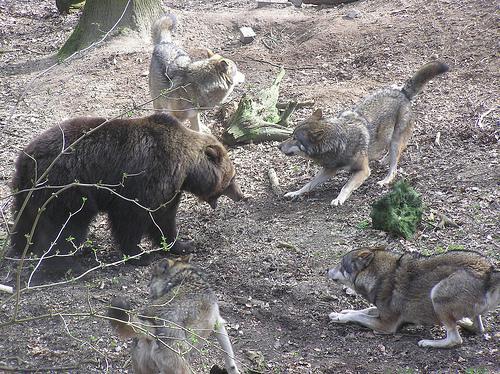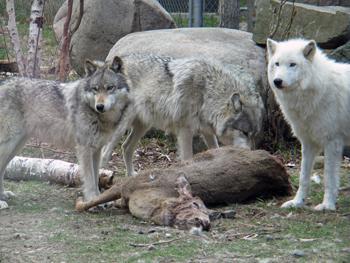The first image is the image on the left, the second image is the image on the right. Given the left and right images, does the statement "One of the images features a single animal." hold true? Answer yes or no. No. The first image is the image on the left, the second image is the image on the right. Examine the images to the left and right. Is the description "There are three wolves in the image pair." accurate? Answer yes or no. No. 